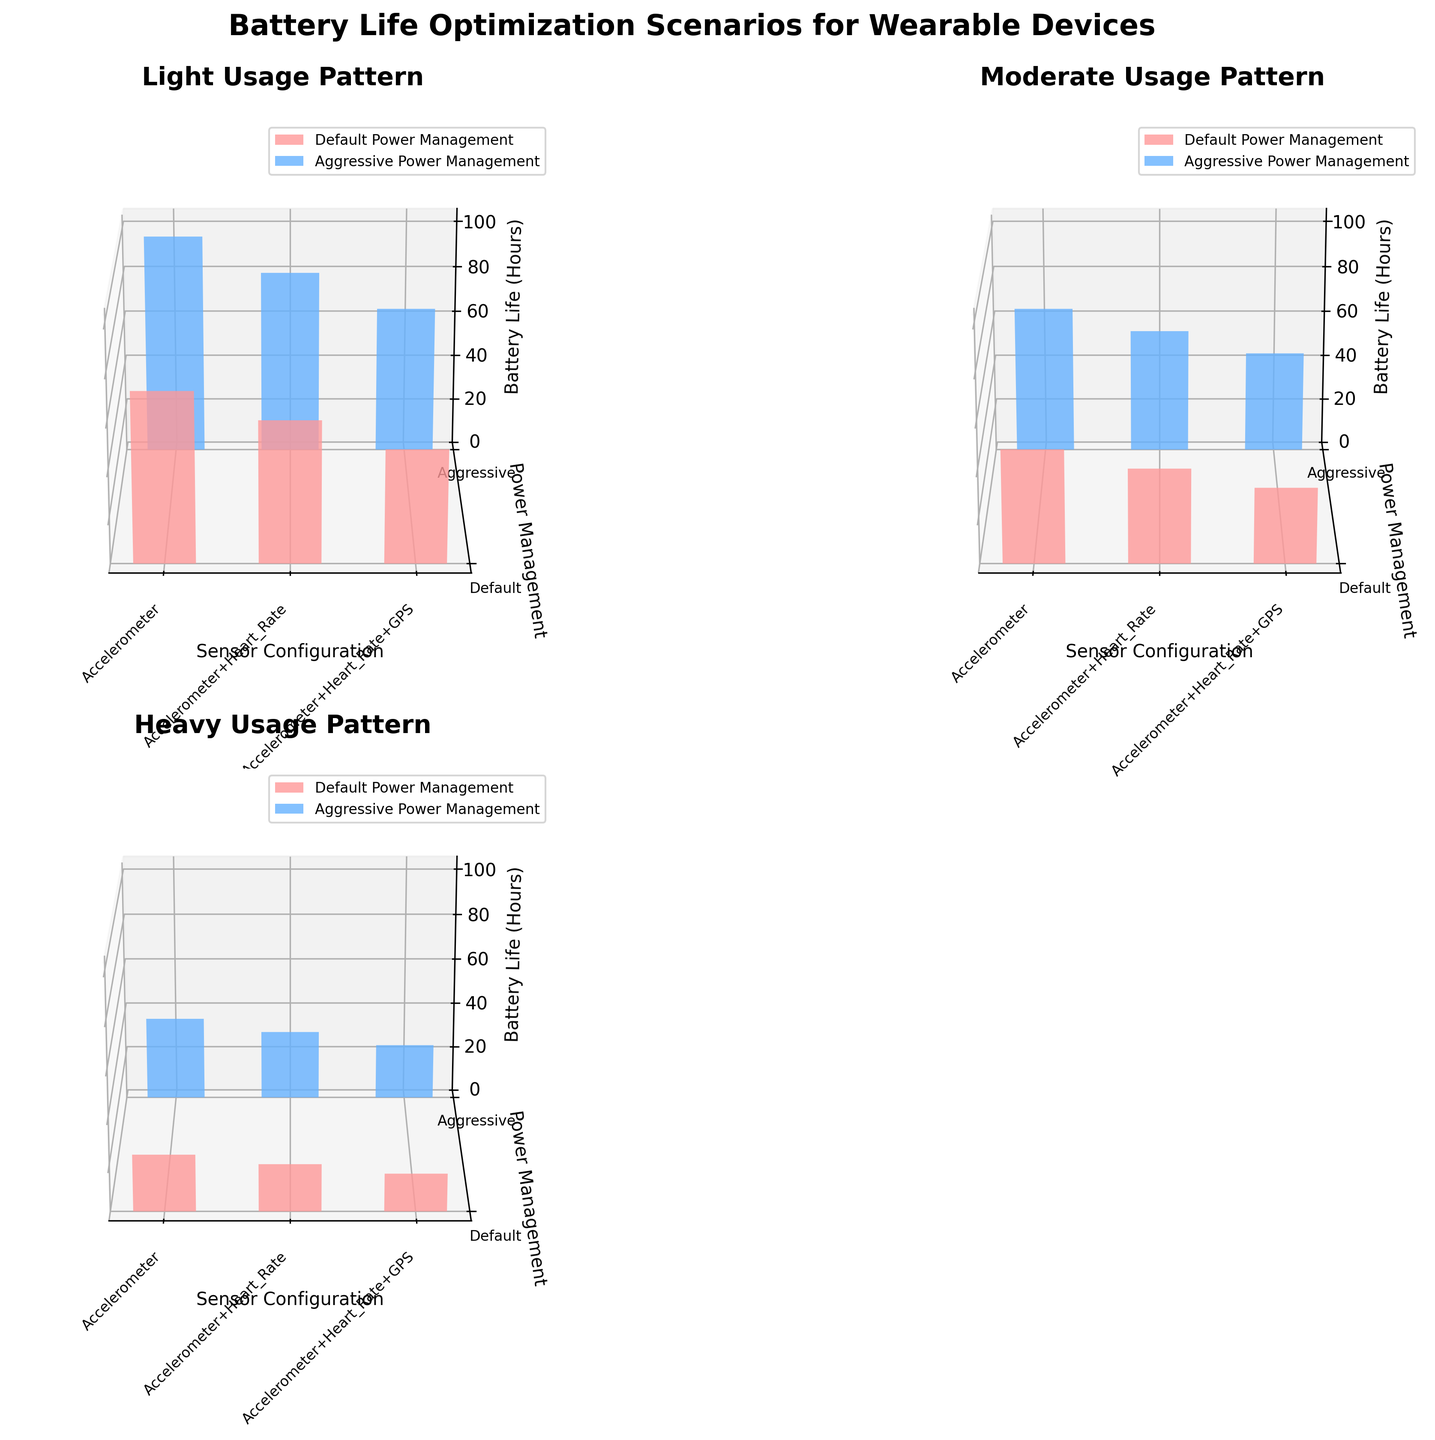What is the title of the figure? The title of the figure is usually located at the top and provides a brief description of what the plot is about. In this case, it is "Battery Life Optimization Scenarios for Wearable Devices".
Answer: Battery Life Optimization Scenarios for Wearable Devices What are the categories shown on the y-axis? The y-axis represents different categories of power management techniques. The three categories are Default, Aggressive, and another power management technique, each labeled clearly along the y-axis.
Answer: Default, Aggressive Which usage pattern shows the highest battery life with the Default power management technique? To find the highest battery life with the Default power management technique, look for the bar with the highest value within the Default category in each subplot. The Light usage pattern shows the highest battery life of 72 hours.
Answer: Light How does the battery life change with different sensor configurations under the Light usage pattern with Aggressive power management? To analyze the changes, compare the bars under the Aggressive power management category for the Light usage pattern subplot. The battery life is 96 hours for Accelerometer, 80 hours for Accelerometer+Heart_Rate, and 64 hours for Accelerometer+Heart_Rate+GPS.
Answer: 96 hours, 80 hours, 64 hours Which power management technique shows the steepest decline in battery life when switching from Light to Heavy usage patterns for the Accelerometer+Heart_Rate+GPS sensor configuration? First, locate the bars representing the Accelerometer+Heart_Rate+GPS sensor configuration in both the Light and Heavy subplots. Compare the battery life changes from Light to Heavy usage patterns for each power management technique. The Default power management technique shows the steepest decline, from 48 hours to 16 hours.
Answer: Default How much longer is the battery life for Moderate usage with Accelerometer+Agressive power management compared to Heavy usage with Accelerometer+Heart_Rate+GPS and Default power management? Locate the battery life values for Moderate usage with Accelerometer+Agressive power management (64 hours) and Heavy usage with Accelerometer+Heart_Rate+GPS and Default power management (16 hours). Subtract the two: 64 - 16 = 48 hours.
Answer: 48 hours Which usage pattern and sensor configuration combination yields the highest battery life? Look at all the bars across each subplot and identify the one with the highest value. Light usage pattern with Accelerometer and Aggressive power management has the highest battery life of 96 hours.
Answer: Light, Accelerometer, Aggressive How does the battery life compare between Default and Aggressive power management techniques across all usage patterns for Accelerometer+Heart_Rate sensor configuration? Compare the bars for Default and Aggressive power management techniques in the Accelerometer+Heart_Rate sensor configuration across each subplot. Light: 60 (Default) vs 80 (Aggressive), Moderate: 40 (Default) vs 54 (Aggressive), Heavy: 20 (Default) vs 30 (Aggressive). In all cases, Aggressive has higher battery life.
Answer: Aggressive has higher battery life across all usage patterns What is the battery life difference between Light usage with Accelerometer+Heart_Rate under Default power management and Heavy usage with the same sensor configuration under Aggressive power management? Locate the bar for Light usage with Accelerometer+Heart_Rate under Default (60 hours) and Heavy usage with Accelerometer+Heart_Rate under Aggressive (30 hours). Subtract the two: 60 - 30 = 30 hours.
Answer: 30 hours 